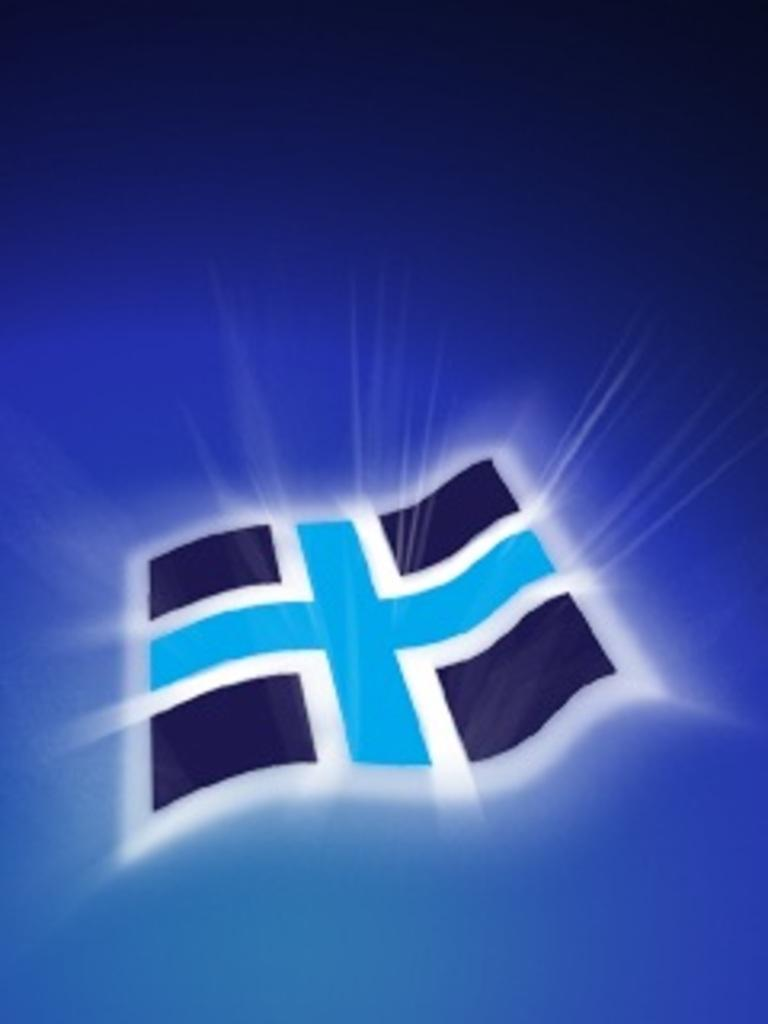What is the color of the background in the image? The background of the image is dark. What can be found in the image besides the background? There is a logo in the image. How many eggs are visible in the image? There are no eggs present in the image. What type of trail can be seen in the image? There is no trail visible in the image. 